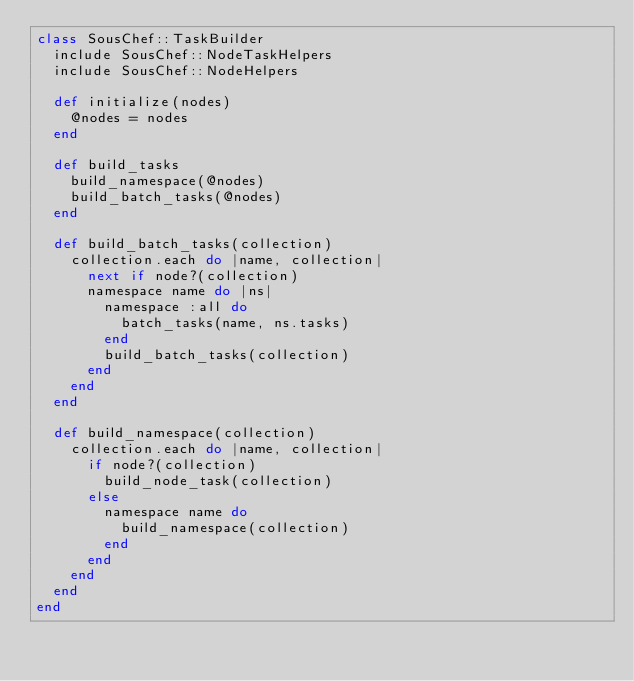Convert code to text. <code><loc_0><loc_0><loc_500><loc_500><_Ruby_>class SousChef::TaskBuilder
  include SousChef::NodeTaskHelpers
  include SousChef::NodeHelpers

  def initialize(nodes)
    @nodes = nodes
  end

  def build_tasks
    build_namespace(@nodes)
    build_batch_tasks(@nodes)
  end

  def build_batch_tasks(collection)
    collection.each do |name, collection|
      next if node?(collection)
      namespace name do |ns|
        namespace :all do
          batch_tasks(name, ns.tasks)
        end
        build_batch_tasks(collection)
      end
    end
  end

  def build_namespace(collection)
    collection.each do |name, collection|
      if node?(collection)
        build_node_task(collection)
      else
        namespace name do
          build_namespace(collection)
        end
      end
    end
  end
end

</code> 